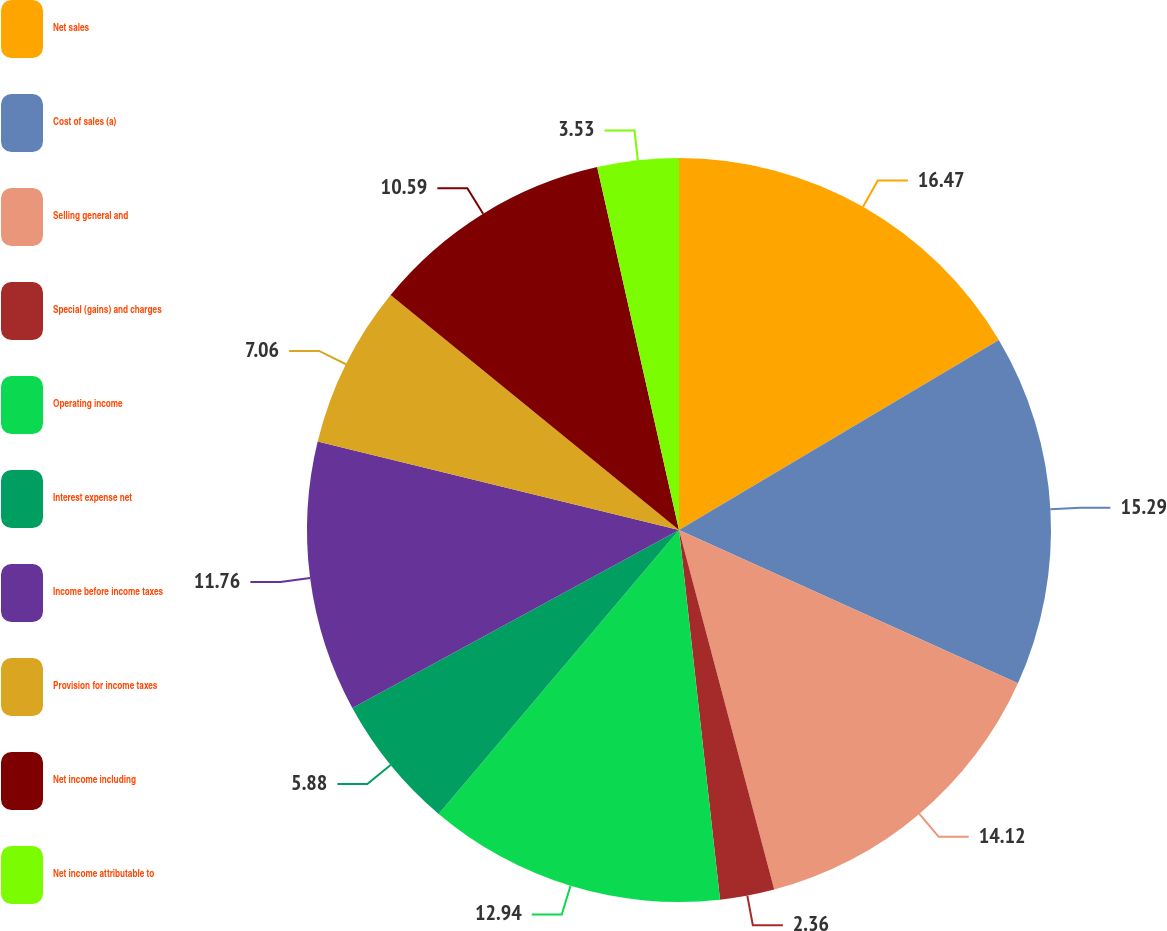Convert chart. <chart><loc_0><loc_0><loc_500><loc_500><pie_chart><fcel>Net sales<fcel>Cost of sales (a)<fcel>Selling general and<fcel>Special (gains) and charges<fcel>Operating income<fcel>Interest expense net<fcel>Income before income taxes<fcel>Provision for income taxes<fcel>Net income including<fcel>Net income attributable to<nl><fcel>16.47%<fcel>15.29%<fcel>14.12%<fcel>2.36%<fcel>12.94%<fcel>5.88%<fcel>11.76%<fcel>7.06%<fcel>10.59%<fcel>3.53%<nl></chart> 